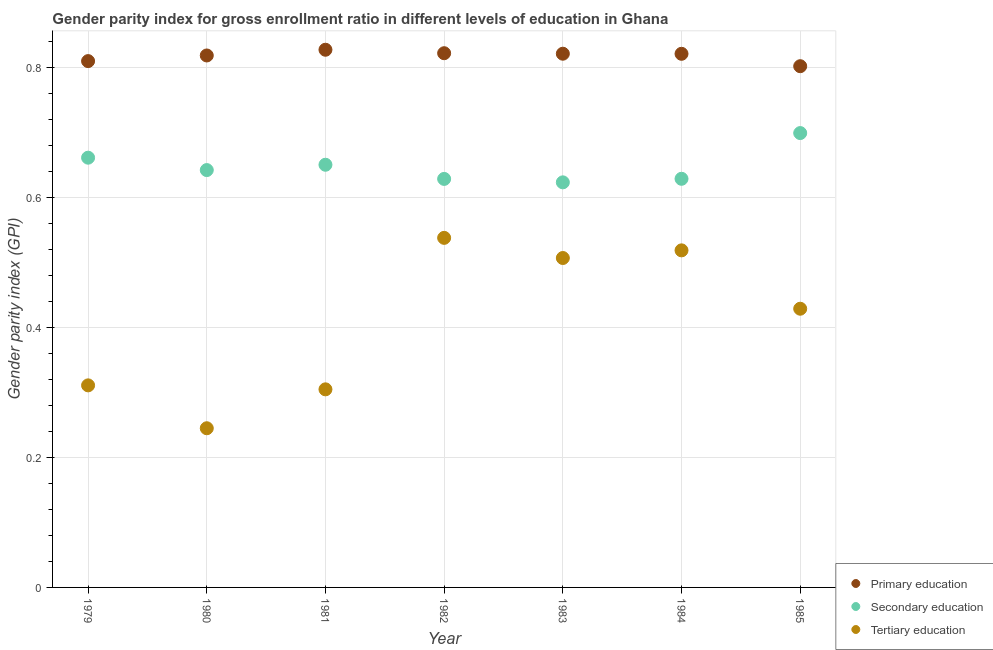How many different coloured dotlines are there?
Provide a short and direct response. 3. Is the number of dotlines equal to the number of legend labels?
Provide a short and direct response. Yes. What is the gender parity index in primary education in 1979?
Provide a short and direct response. 0.81. Across all years, what is the maximum gender parity index in primary education?
Your answer should be compact. 0.83. Across all years, what is the minimum gender parity index in primary education?
Your answer should be very brief. 0.8. In which year was the gender parity index in secondary education minimum?
Your response must be concise. 1983. What is the total gender parity index in tertiary education in the graph?
Provide a short and direct response. 2.85. What is the difference between the gender parity index in tertiary education in 1979 and that in 1983?
Make the answer very short. -0.2. What is the difference between the gender parity index in tertiary education in 1982 and the gender parity index in secondary education in 1984?
Offer a very short reply. -0.09. What is the average gender parity index in secondary education per year?
Make the answer very short. 0.65. In the year 1983, what is the difference between the gender parity index in secondary education and gender parity index in primary education?
Your response must be concise. -0.2. What is the ratio of the gender parity index in primary education in 1981 to that in 1983?
Give a very brief answer. 1.01. What is the difference between the highest and the second highest gender parity index in tertiary education?
Give a very brief answer. 0.02. What is the difference between the highest and the lowest gender parity index in tertiary education?
Keep it short and to the point. 0.29. Is the gender parity index in secondary education strictly greater than the gender parity index in primary education over the years?
Provide a short and direct response. No. Is the gender parity index in secondary education strictly less than the gender parity index in primary education over the years?
Ensure brevity in your answer.  Yes. How many dotlines are there?
Your response must be concise. 3. What is the difference between two consecutive major ticks on the Y-axis?
Offer a terse response. 0.2. Does the graph contain any zero values?
Give a very brief answer. No. Does the graph contain grids?
Offer a terse response. Yes. How many legend labels are there?
Provide a short and direct response. 3. How are the legend labels stacked?
Provide a short and direct response. Vertical. What is the title of the graph?
Your answer should be compact. Gender parity index for gross enrollment ratio in different levels of education in Ghana. Does "Secondary" appear as one of the legend labels in the graph?
Provide a succinct answer. No. What is the label or title of the X-axis?
Your answer should be very brief. Year. What is the label or title of the Y-axis?
Make the answer very short. Gender parity index (GPI). What is the Gender parity index (GPI) in Primary education in 1979?
Offer a terse response. 0.81. What is the Gender parity index (GPI) in Secondary education in 1979?
Ensure brevity in your answer.  0.66. What is the Gender parity index (GPI) of Tertiary education in 1979?
Your answer should be very brief. 0.31. What is the Gender parity index (GPI) in Primary education in 1980?
Keep it short and to the point. 0.82. What is the Gender parity index (GPI) of Secondary education in 1980?
Offer a very short reply. 0.64. What is the Gender parity index (GPI) of Tertiary education in 1980?
Your answer should be very brief. 0.24. What is the Gender parity index (GPI) in Primary education in 1981?
Provide a short and direct response. 0.83. What is the Gender parity index (GPI) in Secondary education in 1981?
Your answer should be compact. 0.65. What is the Gender parity index (GPI) of Tertiary education in 1981?
Provide a succinct answer. 0.3. What is the Gender parity index (GPI) of Primary education in 1982?
Offer a terse response. 0.82. What is the Gender parity index (GPI) in Secondary education in 1982?
Your answer should be very brief. 0.63. What is the Gender parity index (GPI) of Tertiary education in 1982?
Provide a succinct answer. 0.54. What is the Gender parity index (GPI) in Primary education in 1983?
Keep it short and to the point. 0.82. What is the Gender parity index (GPI) of Secondary education in 1983?
Keep it short and to the point. 0.62. What is the Gender parity index (GPI) of Tertiary education in 1983?
Provide a succinct answer. 0.51. What is the Gender parity index (GPI) of Primary education in 1984?
Your answer should be compact. 0.82. What is the Gender parity index (GPI) of Secondary education in 1984?
Your answer should be very brief. 0.63. What is the Gender parity index (GPI) of Tertiary education in 1984?
Your response must be concise. 0.52. What is the Gender parity index (GPI) of Primary education in 1985?
Ensure brevity in your answer.  0.8. What is the Gender parity index (GPI) in Secondary education in 1985?
Provide a short and direct response. 0.7. What is the Gender parity index (GPI) in Tertiary education in 1985?
Offer a very short reply. 0.43. Across all years, what is the maximum Gender parity index (GPI) of Primary education?
Ensure brevity in your answer.  0.83. Across all years, what is the maximum Gender parity index (GPI) in Secondary education?
Offer a very short reply. 0.7. Across all years, what is the maximum Gender parity index (GPI) of Tertiary education?
Keep it short and to the point. 0.54. Across all years, what is the minimum Gender parity index (GPI) of Primary education?
Provide a short and direct response. 0.8. Across all years, what is the minimum Gender parity index (GPI) in Secondary education?
Keep it short and to the point. 0.62. Across all years, what is the minimum Gender parity index (GPI) in Tertiary education?
Give a very brief answer. 0.24. What is the total Gender parity index (GPI) of Primary education in the graph?
Make the answer very short. 5.72. What is the total Gender parity index (GPI) in Secondary education in the graph?
Give a very brief answer. 4.53. What is the total Gender parity index (GPI) in Tertiary education in the graph?
Your answer should be compact. 2.85. What is the difference between the Gender parity index (GPI) of Primary education in 1979 and that in 1980?
Make the answer very short. -0.01. What is the difference between the Gender parity index (GPI) of Secondary education in 1979 and that in 1980?
Your response must be concise. 0.02. What is the difference between the Gender parity index (GPI) of Tertiary education in 1979 and that in 1980?
Keep it short and to the point. 0.07. What is the difference between the Gender parity index (GPI) in Primary education in 1979 and that in 1981?
Offer a terse response. -0.02. What is the difference between the Gender parity index (GPI) of Secondary education in 1979 and that in 1981?
Keep it short and to the point. 0.01. What is the difference between the Gender parity index (GPI) of Tertiary education in 1979 and that in 1981?
Provide a short and direct response. 0.01. What is the difference between the Gender parity index (GPI) of Primary education in 1979 and that in 1982?
Your response must be concise. -0.01. What is the difference between the Gender parity index (GPI) of Secondary education in 1979 and that in 1982?
Offer a terse response. 0.03. What is the difference between the Gender parity index (GPI) of Tertiary education in 1979 and that in 1982?
Make the answer very short. -0.23. What is the difference between the Gender parity index (GPI) of Primary education in 1979 and that in 1983?
Ensure brevity in your answer.  -0.01. What is the difference between the Gender parity index (GPI) in Secondary education in 1979 and that in 1983?
Ensure brevity in your answer.  0.04. What is the difference between the Gender parity index (GPI) of Tertiary education in 1979 and that in 1983?
Your answer should be very brief. -0.2. What is the difference between the Gender parity index (GPI) of Primary education in 1979 and that in 1984?
Provide a short and direct response. -0.01. What is the difference between the Gender parity index (GPI) in Secondary education in 1979 and that in 1984?
Keep it short and to the point. 0.03. What is the difference between the Gender parity index (GPI) in Tertiary education in 1979 and that in 1984?
Provide a short and direct response. -0.21. What is the difference between the Gender parity index (GPI) of Primary education in 1979 and that in 1985?
Ensure brevity in your answer.  0.01. What is the difference between the Gender parity index (GPI) in Secondary education in 1979 and that in 1985?
Offer a very short reply. -0.04. What is the difference between the Gender parity index (GPI) in Tertiary education in 1979 and that in 1985?
Make the answer very short. -0.12. What is the difference between the Gender parity index (GPI) in Primary education in 1980 and that in 1981?
Your answer should be very brief. -0.01. What is the difference between the Gender parity index (GPI) in Secondary education in 1980 and that in 1981?
Your response must be concise. -0.01. What is the difference between the Gender parity index (GPI) of Tertiary education in 1980 and that in 1981?
Your answer should be compact. -0.06. What is the difference between the Gender parity index (GPI) of Primary education in 1980 and that in 1982?
Your response must be concise. -0. What is the difference between the Gender parity index (GPI) of Secondary education in 1980 and that in 1982?
Your answer should be compact. 0.01. What is the difference between the Gender parity index (GPI) of Tertiary education in 1980 and that in 1982?
Keep it short and to the point. -0.29. What is the difference between the Gender parity index (GPI) in Primary education in 1980 and that in 1983?
Offer a terse response. -0. What is the difference between the Gender parity index (GPI) of Secondary education in 1980 and that in 1983?
Your answer should be compact. 0.02. What is the difference between the Gender parity index (GPI) in Tertiary education in 1980 and that in 1983?
Offer a terse response. -0.26. What is the difference between the Gender parity index (GPI) of Primary education in 1980 and that in 1984?
Provide a succinct answer. -0. What is the difference between the Gender parity index (GPI) of Secondary education in 1980 and that in 1984?
Offer a very short reply. 0.01. What is the difference between the Gender parity index (GPI) of Tertiary education in 1980 and that in 1984?
Give a very brief answer. -0.27. What is the difference between the Gender parity index (GPI) of Primary education in 1980 and that in 1985?
Offer a terse response. 0.02. What is the difference between the Gender parity index (GPI) of Secondary education in 1980 and that in 1985?
Provide a succinct answer. -0.06. What is the difference between the Gender parity index (GPI) of Tertiary education in 1980 and that in 1985?
Keep it short and to the point. -0.18. What is the difference between the Gender parity index (GPI) of Primary education in 1981 and that in 1982?
Offer a very short reply. 0.01. What is the difference between the Gender parity index (GPI) in Secondary education in 1981 and that in 1982?
Offer a terse response. 0.02. What is the difference between the Gender parity index (GPI) of Tertiary education in 1981 and that in 1982?
Provide a succinct answer. -0.23. What is the difference between the Gender parity index (GPI) in Primary education in 1981 and that in 1983?
Ensure brevity in your answer.  0.01. What is the difference between the Gender parity index (GPI) in Secondary education in 1981 and that in 1983?
Make the answer very short. 0.03. What is the difference between the Gender parity index (GPI) in Tertiary education in 1981 and that in 1983?
Keep it short and to the point. -0.2. What is the difference between the Gender parity index (GPI) of Primary education in 1981 and that in 1984?
Give a very brief answer. 0.01. What is the difference between the Gender parity index (GPI) in Secondary education in 1981 and that in 1984?
Offer a very short reply. 0.02. What is the difference between the Gender parity index (GPI) of Tertiary education in 1981 and that in 1984?
Provide a succinct answer. -0.21. What is the difference between the Gender parity index (GPI) of Primary education in 1981 and that in 1985?
Offer a terse response. 0.03. What is the difference between the Gender parity index (GPI) of Secondary education in 1981 and that in 1985?
Provide a succinct answer. -0.05. What is the difference between the Gender parity index (GPI) in Tertiary education in 1981 and that in 1985?
Your answer should be very brief. -0.12. What is the difference between the Gender parity index (GPI) in Primary education in 1982 and that in 1983?
Give a very brief answer. 0. What is the difference between the Gender parity index (GPI) in Secondary education in 1982 and that in 1983?
Your answer should be compact. 0.01. What is the difference between the Gender parity index (GPI) in Tertiary education in 1982 and that in 1983?
Provide a succinct answer. 0.03. What is the difference between the Gender parity index (GPI) in Primary education in 1982 and that in 1984?
Your response must be concise. 0. What is the difference between the Gender parity index (GPI) in Secondary education in 1982 and that in 1984?
Your response must be concise. -0. What is the difference between the Gender parity index (GPI) of Tertiary education in 1982 and that in 1984?
Your answer should be compact. 0.02. What is the difference between the Gender parity index (GPI) of Primary education in 1982 and that in 1985?
Ensure brevity in your answer.  0.02. What is the difference between the Gender parity index (GPI) of Secondary education in 1982 and that in 1985?
Offer a very short reply. -0.07. What is the difference between the Gender parity index (GPI) of Tertiary education in 1982 and that in 1985?
Keep it short and to the point. 0.11. What is the difference between the Gender parity index (GPI) of Primary education in 1983 and that in 1984?
Ensure brevity in your answer.  0. What is the difference between the Gender parity index (GPI) of Secondary education in 1983 and that in 1984?
Your answer should be compact. -0.01. What is the difference between the Gender parity index (GPI) of Tertiary education in 1983 and that in 1984?
Give a very brief answer. -0.01. What is the difference between the Gender parity index (GPI) of Primary education in 1983 and that in 1985?
Keep it short and to the point. 0.02. What is the difference between the Gender parity index (GPI) of Secondary education in 1983 and that in 1985?
Your response must be concise. -0.08. What is the difference between the Gender parity index (GPI) in Tertiary education in 1983 and that in 1985?
Offer a very short reply. 0.08. What is the difference between the Gender parity index (GPI) of Primary education in 1984 and that in 1985?
Keep it short and to the point. 0.02. What is the difference between the Gender parity index (GPI) of Secondary education in 1984 and that in 1985?
Offer a terse response. -0.07. What is the difference between the Gender parity index (GPI) in Tertiary education in 1984 and that in 1985?
Your response must be concise. 0.09. What is the difference between the Gender parity index (GPI) in Primary education in 1979 and the Gender parity index (GPI) in Secondary education in 1980?
Ensure brevity in your answer.  0.17. What is the difference between the Gender parity index (GPI) of Primary education in 1979 and the Gender parity index (GPI) of Tertiary education in 1980?
Give a very brief answer. 0.56. What is the difference between the Gender parity index (GPI) in Secondary education in 1979 and the Gender parity index (GPI) in Tertiary education in 1980?
Your answer should be compact. 0.42. What is the difference between the Gender parity index (GPI) of Primary education in 1979 and the Gender parity index (GPI) of Secondary education in 1981?
Make the answer very short. 0.16. What is the difference between the Gender parity index (GPI) in Primary education in 1979 and the Gender parity index (GPI) in Tertiary education in 1981?
Your answer should be compact. 0.5. What is the difference between the Gender parity index (GPI) of Secondary education in 1979 and the Gender parity index (GPI) of Tertiary education in 1981?
Give a very brief answer. 0.36. What is the difference between the Gender parity index (GPI) in Primary education in 1979 and the Gender parity index (GPI) in Secondary education in 1982?
Your answer should be very brief. 0.18. What is the difference between the Gender parity index (GPI) of Primary education in 1979 and the Gender parity index (GPI) of Tertiary education in 1982?
Your answer should be very brief. 0.27. What is the difference between the Gender parity index (GPI) in Secondary education in 1979 and the Gender parity index (GPI) in Tertiary education in 1982?
Provide a short and direct response. 0.12. What is the difference between the Gender parity index (GPI) of Primary education in 1979 and the Gender parity index (GPI) of Secondary education in 1983?
Your answer should be very brief. 0.19. What is the difference between the Gender parity index (GPI) in Primary education in 1979 and the Gender parity index (GPI) in Tertiary education in 1983?
Give a very brief answer. 0.3. What is the difference between the Gender parity index (GPI) in Secondary education in 1979 and the Gender parity index (GPI) in Tertiary education in 1983?
Provide a succinct answer. 0.15. What is the difference between the Gender parity index (GPI) in Primary education in 1979 and the Gender parity index (GPI) in Secondary education in 1984?
Ensure brevity in your answer.  0.18. What is the difference between the Gender parity index (GPI) in Primary education in 1979 and the Gender parity index (GPI) in Tertiary education in 1984?
Keep it short and to the point. 0.29. What is the difference between the Gender parity index (GPI) of Secondary education in 1979 and the Gender parity index (GPI) of Tertiary education in 1984?
Provide a succinct answer. 0.14. What is the difference between the Gender parity index (GPI) in Primary education in 1979 and the Gender parity index (GPI) in Secondary education in 1985?
Your response must be concise. 0.11. What is the difference between the Gender parity index (GPI) of Primary education in 1979 and the Gender parity index (GPI) of Tertiary education in 1985?
Make the answer very short. 0.38. What is the difference between the Gender parity index (GPI) of Secondary education in 1979 and the Gender parity index (GPI) of Tertiary education in 1985?
Offer a terse response. 0.23. What is the difference between the Gender parity index (GPI) of Primary education in 1980 and the Gender parity index (GPI) of Secondary education in 1981?
Provide a short and direct response. 0.17. What is the difference between the Gender parity index (GPI) of Primary education in 1980 and the Gender parity index (GPI) of Tertiary education in 1981?
Your response must be concise. 0.51. What is the difference between the Gender parity index (GPI) of Secondary education in 1980 and the Gender parity index (GPI) of Tertiary education in 1981?
Provide a succinct answer. 0.34. What is the difference between the Gender parity index (GPI) in Primary education in 1980 and the Gender parity index (GPI) in Secondary education in 1982?
Offer a terse response. 0.19. What is the difference between the Gender parity index (GPI) in Primary education in 1980 and the Gender parity index (GPI) in Tertiary education in 1982?
Make the answer very short. 0.28. What is the difference between the Gender parity index (GPI) of Secondary education in 1980 and the Gender parity index (GPI) of Tertiary education in 1982?
Keep it short and to the point. 0.1. What is the difference between the Gender parity index (GPI) of Primary education in 1980 and the Gender parity index (GPI) of Secondary education in 1983?
Give a very brief answer. 0.2. What is the difference between the Gender parity index (GPI) of Primary education in 1980 and the Gender parity index (GPI) of Tertiary education in 1983?
Your answer should be very brief. 0.31. What is the difference between the Gender parity index (GPI) in Secondary education in 1980 and the Gender parity index (GPI) in Tertiary education in 1983?
Ensure brevity in your answer.  0.14. What is the difference between the Gender parity index (GPI) in Primary education in 1980 and the Gender parity index (GPI) in Secondary education in 1984?
Offer a very short reply. 0.19. What is the difference between the Gender parity index (GPI) of Primary education in 1980 and the Gender parity index (GPI) of Tertiary education in 1984?
Ensure brevity in your answer.  0.3. What is the difference between the Gender parity index (GPI) of Secondary education in 1980 and the Gender parity index (GPI) of Tertiary education in 1984?
Your answer should be very brief. 0.12. What is the difference between the Gender parity index (GPI) in Primary education in 1980 and the Gender parity index (GPI) in Secondary education in 1985?
Keep it short and to the point. 0.12. What is the difference between the Gender parity index (GPI) in Primary education in 1980 and the Gender parity index (GPI) in Tertiary education in 1985?
Provide a succinct answer. 0.39. What is the difference between the Gender parity index (GPI) in Secondary education in 1980 and the Gender parity index (GPI) in Tertiary education in 1985?
Offer a terse response. 0.21. What is the difference between the Gender parity index (GPI) of Primary education in 1981 and the Gender parity index (GPI) of Secondary education in 1982?
Give a very brief answer. 0.2. What is the difference between the Gender parity index (GPI) in Primary education in 1981 and the Gender parity index (GPI) in Tertiary education in 1982?
Give a very brief answer. 0.29. What is the difference between the Gender parity index (GPI) of Secondary education in 1981 and the Gender parity index (GPI) of Tertiary education in 1982?
Offer a very short reply. 0.11. What is the difference between the Gender parity index (GPI) in Primary education in 1981 and the Gender parity index (GPI) in Secondary education in 1983?
Make the answer very short. 0.2. What is the difference between the Gender parity index (GPI) of Primary education in 1981 and the Gender parity index (GPI) of Tertiary education in 1983?
Offer a very short reply. 0.32. What is the difference between the Gender parity index (GPI) of Secondary education in 1981 and the Gender parity index (GPI) of Tertiary education in 1983?
Provide a short and direct response. 0.14. What is the difference between the Gender parity index (GPI) of Primary education in 1981 and the Gender parity index (GPI) of Secondary education in 1984?
Your answer should be compact. 0.2. What is the difference between the Gender parity index (GPI) of Primary education in 1981 and the Gender parity index (GPI) of Tertiary education in 1984?
Your response must be concise. 0.31. What is the difference between the Gender parity index (GPI) of Secondary education in 1981 and the Gender parity index (GPI) of Tertiary education in 1984?
Make the answer very short. 0.13. What is the difference between the Gender parity index (GPI) of Primary education in 1981 and the Gender parity index (GPI) of Secondary education in 1985?
Keep it short and to the point. 0.13. What is the difference between the Gender parity index (GPI) in Primary education in 1981 and the Gender parity index (GPI) in Tertiary education in 1985?
Offer a terse response. 0.4. What is the difference between the Gender parity index (GPI) in Secondary education in 1981 and the Gender parity index (GPI) in Tertiary education in 1985?
Your answer should be compact. 0.22. What is the difference between the Gender parity index (GPI) of Primary education in 1982 and the Gender parity index (GPI) of Secondary education in 1983?
Offer a terse response. 0.2. What is the difference between the Gender parity index (GPI) in Primary education in 1982 and the Gender parity index (GPI) in Tertiary education in 1983?
Keep it short and to the point. 0.32. What is the difference between the Gender parity index (GPI) in Secondary education in 1982 and the Gender parity index (GPI) in Tertiary education in 1983?
Your answer should be compact. 0.12. What is the difference between the Gender parity index (GPI) of Primary education in 1982 and the Gender parity index (GPI) of Secondary education in 1984?
Offer a very short reply. 0.19. What is the difference between the Gender parity index (GPI) of Primary education in 1982 and the Gender parity index (GPI) of Tertiary education in 1984?
Your response must be concise. 0.3. What is the difference between the Gender parity index (GPI) in Secondary education in 1982 and the Gender parity index (GPI) in Tertiary education in 1984?
Your response must be concise. 0.11. What is the difference between the Gender parity index (GPI) in Primary education in 1982 and the Gender parity index (GPI) in Secondary education in 1985?
Provide a succinct answer. 0.12. What is the difference between the Gender parity index (GPI) in Primary education in 1982 and the Gender parity index (GPI) in Tertiary education in 1985?
Make the answer very short. 0.39. What is the difference between the Gender parity index (GPI) in Secondary education in 1982 and the Gender parity index (GPI) in Tertiary education in 1985?
Make the answer very short. 0.2. What is the difference between the Gender parity index (GPI) in Primary education in 1983 and the Gender parity index (GPI) in Secondary education in 1984?
Your answer should be very brief. 0.19. What is the difference between the Gender parity index (GPI) in Primary education in 1983 and the Gender parity index (GPI) in Tertiary education in 1984?
Keep it short and to the point. 0.3. What is the difference between the Gender parity index (GPI) in Secondary education in 1983 and the Gender parity index (GPI) in Tertiary education in 1984?
Offer a very short reply. 0.1. What is the difference between the Gender parity index (GPI) in Primary education in 1983 and the Gender parity index (GPI) in Secondary education in 1985?
Provide a succinct answer. 0.12. What is the difference between the Gender parity index (GPI) of Primary education in 1983 and the Gender parity index (GPI) of Tertiary education in 1985?
Give a very brief answer. 0.39. What is the difference between the Gender parity index (GPI) in Secondary education in 1983 and the Gender parity index (GPI) in Tertiary education in 1985?
Provide a succinct answer. 0.19. What is the difference between the Gender parity index (GPI) in Primary education in 1984 and the Gender parity index (GPI) in Secondary education in 1985?
Provide a short and direct response. 0.12. What is the difference between the Gender parity index (GPI) in Primary education in 1984 and the Gender parity index (GPI) in Tertiary education in 1985?
Provide a short and direct response. 0.39. What is the difference between the Gender parity index (GPI) of Secondary education in 1984 and the Gender parity index (GPI) of Tertiary education in 1985?
Offer a very short reply. 0.2. What is the average Gender parity index (GPI) in Primary education per year?
Keep it short and to the point. 0.82. What is the average Gender parity index (GPI) in Secondary education per year?
Give a very brief answer. 0.65. What is the average Gender parity index (GPI) of Tertiary education per year?
Offer a very short reply. 0.41. In the year 1979, what is the difference between the Gender parity index (GPI) in Primary education and Gender parity index (GPI) in Secondary education?
Keep it short and to the point. 0.15. In the year 1979, what is the difference between the Gender parity index (GPI) of Primary education and Gender parity index (GPI) of Tertiary education?
Provide a succinct answer. 0.5. In the year 1979, what is the difference between the Gender parity index (GPI) of Secondary education and Gender parity index (GPI) of Tertiary education?
Provide a short and direct response. 0.35. In the year 1980, what is the difference between the Gender parity index (GPI) of Primary education and Gender parity index (GPI) of Secondary education?
Your answer should be compact. 0.18. In the year 1980, what is the difference between the Gender parity index (GPI) in Primary education and Gender parity index (GPI) in Tertiary education?
Offer a terse response. 0.57. In the year 1980, what is the difference between the Gender parity index (GPI) in Secondary education and Gender parity index (GPI) in Tertiary education?
Provide a succinct answer. 0.4. In the year 1981, what is the difference between the Gender parity index (GPI) in Primary education and Gender parity index (GPI) in Secondary education?
Offer a terse response. 0.18. In the year 1981, what is the difference between the Gender parity index (GPI) in Primary education and Gender parity index (GPI) in Tertiary education?
Make the answer very short. 0.52. In the year 1981, what is the difference between the Gender parity index (GPI) of Secondary education and Gender parity index (GPI) of Tertiary education?
Provide a succinct answer. 0.35. In the year 1982, what is the difference between the Gender parity index (GPI) of Primary education and Gender parity index (GPI) of Secondary education?
Make the answer very short. 0.19. In the year 1982, what is the difference between the Gender parity index (GPI) in Primary education and Gender parity index (GPI) in Tertiary education?
Provide a succinct answer. 0.28. In the year 1982, what is the difference between the Gender parity index (GPI) in Secondary education and Gender parity index (GPI) in Tertiary education?
Keep it short and to the point. 0.09. In the year 1983, what is the difference between the Gender parity index (GPI) in Primary education and Gender parity index (GPI) in Secondary education?
Keep it short and to the point. 0.2. In the year 1983, what is the difference between the Gender parity index (GPI) of Primary education and Gender parity index (GPI) of Tertiary education?
Your answer should be compact. 0.31. In the year 1983, what is the difference between the Gender parity index (GPI) of Secondary education and Gender parity index (GPI) of Tertiary education?
Ensure brevity in your answer.  0.12. In the year 1984, what is the difference between the Gender parity index (GPI) of Primary education and Gender parity index (GPI) of Secondary education?
Your answer should be compact. 0.19. In the year 1984, what is the difference between the Gender parity index (GPI) of Primary education and Gender parity index (GPI) of Tertiary education?
Provide a succinct answer. 0.3. In the year 1984, what is the difference between the Gender parity index (GPI) of Secondary education and Gender parity index (GPI) of Tertiary education?
Provide a succinct answer. 0.11. In the year 1985, what is the difference between the Gender parity index (GPI) in Primary education and Gender parity index (GPI) in Secondary education?
Provide a succinct answer. 0.1. In the year 1985, what is the difference between the Gender parity index (GPI) in Primary education and Gender parity index (GPI) in Tertiary education?
Your answer should be very brief. 0.37. In the year 1985, what is the difference between the Gender parity index (GPI) in Secondary education and Gender parity index (GPI) in Tertiary education?
Provide a succinct answer. 0.27. What is the ratio of the Gender parity index (GPI) of Secondary education in 1979 to that in 1980?
Make the answer very short. 1.03. What is the ratio of the Gender parity index (GPI) in Tertiary education in 1979 to that in 1980?
Ensure brevity in your answer.  1.27. What is the ratio of the Gender parity index (GPI) of Primary education in 1979 to that in 1981?
Your response must be concise. 0.98. What is the ratio of the Gender parity index (GPI) of Secondary education in 1979 to that in 1981?
Offer a very short reply. 1.02. What is the ratio of the Gender parity index (GPI) in Tertiary education in 1979 to that in 1981?
Your answer should be very brief. 1.02. What is the ratio of the Gender parity index (GPI) of Primary education in 1979 to that in 1982?
Provide a short and direct response. 0.99. What is the ratio of the Gender parity index (GPI) in Secondary education in 1979 to that in 1982?
Ensure brevity in your answer.  1.05. What is the ratio of the Gender parity index (GPI) of Tertiary education in 1979 to that in 1982?
Provide a short and direct response. 0.58. What is the ratio of the Gender parity index (GPI) in Primary education in 1979 to that in 1983?
Provide a short and direct response. 0.99. What is the ratio of the Gender parity index (GPI) of Secondary education in 1979 to that in 1983?
Your answer should be compact. 1.06. What is the ratio of the Gender parity index (GPI) of Tertiary education in 1979 to that in 1983?
Keep it short and to the point. 0.61. What is the ratio of the Gender parity index (GPI) of Primary education in 1979 to that in 1984?
Your answer should be compact. 0.99. What is the ratio of the Gender parity index (GPI) of Secondary education in 1979 to that in 1984?
Your answer should be compact. 1.05. What is the ratio of the Gender parity index (GPI) of Tertiary education in 1979 to that in 1984?
Your answer should be very brief. 0.6. What is the ratio of the Gender parity index (GPI) of Primary education in 1979 to that in 1985?
Make the answer very short. 1.01. What is the ratio of the Gender parity index (GPI) of Secondary education in 1979 to that in 1985?
Keep it short and to the point. 0.95. What is the ratio of the Gender parity index (GPI) in Tertiary education in 1979 to that in 1985?
Your answer should be very brief. 0.72. What is the ratio of the Gender parity index (GPI) in Secondary education in 1980 to that in 1981?
Your answer should be compact. 0.99. What is the ratio of the Gender parity index (GPI) in Tertiary education in 1980 to that in 1981?
Make the answer very short. 0.8. What is the ratio of the Gender parity index (GPI) of Secondary education in 1980 to that in 1982?
Offer a terse response. 1.02. What is the ratio of the Gender parity index (GPI) in Tertiary education in 1980 to that in 1982?
Make the answer very short. 0.46. What is the ratio of the Gender parity index (GPI) in Primary education in 1980 to that in 1983?
Your response must be concise. 1. What is the ratio of the Gender parity index (GPI) in Secondary education in 1980 to that in 1983?
Keep it short and to the point. 1.03. What is the ratio of the Gender parity index (GPI) in Tertiary education in 1980 to that in 1983?
Give a very brief answer. 0.48. What is the ratio of the Gender parity index (GPI) in Secondary education in 1980 to that in 1984?
Ensure brevity in your answer.  1.02. What is the ratio of the Gender parity index (GPI) of Tertiary education in 1980 to that in 1984?
Ensure brevity in your answer.  0.47. What is the ratio of the Gender parity index (GPI) of Primary education in 1980 to that in 1985?
Give a very brief answer. 1.02. What is the ratio of the Gender parity index (GPI) of Secondary education in 1980 to that in 1985?
Offer a very short reply. 0.92. What is the ratio of the Gender parity index (GPI) of Tertiary education in 1980 to that in 1985?
Provide a short and direct response. 0.57. What is the ratio of the Gender parity index (GPI) of Secondary education in 1981 to that in 1982?
Offer a terse response. 1.03. What is the ratio of the Gender parity index (GPI) in Tertiary education in 1981 to that in 1982?
Offer a very short reply. 0.57. What is the ratio of the Gender parity index (GPI) in Primary education in 1981 to that in 1983?
Make the answer very short. 1.01. What is the ratio of the Gender parity index (GPI) of Secondary education in 1981 to that in 1983?
Provide a succinct answer. 1.04. What is the ratio of the Gender parity index (GPI) of Tertiary education in 1981 to that in 1983?
Offer a terse response. 0.6. What is the ratio of the Gender parity index (GPI) of Primary education in 1981 to that in 1984?
Provide a short and direct response. 1.01. What is the ratio of the Gender parity index (GPI) of Secondary education in 1981 to that in 1984?
Provide a succinct answer. 1.03. What is the ratio of the Gender parity index (GPI) in Tertiary education in 1981 to that in 1984?
Offer a terse response. 0.59. What is the ratio of the Gender parity index (GPI) of Primary education in 1981 to that in 1985?
Your answer should be very brief. 1.03. What is the ratio of the Gender parity index (GPI) in Secondary education in 1981 to that in 1985?
Your answer should be very brief. 0.93. What is the ratio of the Gender parity index (GPI) of Tertiary education in 1981 to that in 1985?
Give a very brief answer. 0.71. What is the ratio of the Gender parity index (GPI) of Primary education in 1982 to that in 1983?
Keep it short and to the point. 1. What is the ratio of the Gender parity index (GPI) in Secondary education in 1982 to that in 1983?
Offer a terse response. 1.01. What is the ratio of the Gender parity index (GPI) in Tertiary education in 1982 to that in 1983?
Your response must be concise. 1.06. What is the ratio of the Gender parity index (GPI) of Primary education in 1982 to that in 1984?
Keep it short and to the point. 1. What is the ratio of the Gender parity index (GPI) of Tertiary education in 1982 to that in 1984?
Offer a very short reply. 1.04. What is the ratio of the Gender parity index (GPI) of Primary education in 1982 to that in 1985?
Provide a short and direct response. 1.02. What is the ratio of the Gender parity index (GPI) in Secondary education in 1982 to that in 1985?
Make the answer very short. 0.9. What is the ratio of the Gender parity index (GPI) in Tertiary education in 1982 to that in 1985?
Keep it short and to the point. 1.25. What is the ratio of the Gender parity index (GPI) in Secondary education in 1983 to that in 1984?
Offer a very short reply. 0.99. What is the ratio of the Gender parity index (GPI) of Tertiary education in 1983 to that in 1984?
Provide a short and direct response. 0.98. What is the ratio of the Gender parity index (GPI) in Primary education in 1983 to that in 1985?
Provide a short and direct response. 1.02. What is the ratio of the Gender parity index (GPI) in Secondary education in 1983 to that in 1985?
Provide a succinct answer. 0.89. What is the ratio of the Gender parity index (GPI) of Tertiary education in 1983 to that in 1985?
Ensure brevity in your answer.  1.18. What is the ratio of the Gender parity index (GPI) in Primary education in 1984 to that in 1985?
Ensure brevity in your answer.  1.02. What is the ratio of the Gender parity index (GPI) in Secondary education in 1984 to that in 1985?
Offer a terse response. 0.9. What is the ratio of the Gender parity index (GPI) in Tertiary education in 1984 to that in 1985?
Make the answer very short. 1.21. What is the difference between the highest and the second highest Gender parity index (GPI) of Primary education?
Provide a succinct answer. 0.01. What is the difference between the highest and the second highest Gender parity index (GPI) of Secondary education?
Provide a short and direct response. 0.04. What is the difference between the highest and the second highest Gender parity index (GPI) of Tertiary education?
Offer a very short reply. 0.02. What is the difference between the highest and the lowest Gender parity index (GPI) of Primary education?
Your answer should be very brief. 0.03. What is the difference between the highest and the lowest Gender parity index (GPI) in Secondary education?
Your answer should be compact. 0.08. What is the difference between the highest and the lowest Gender parity index (GPI) of Tertiary education?
Provide a short and direct response. 0.29. 